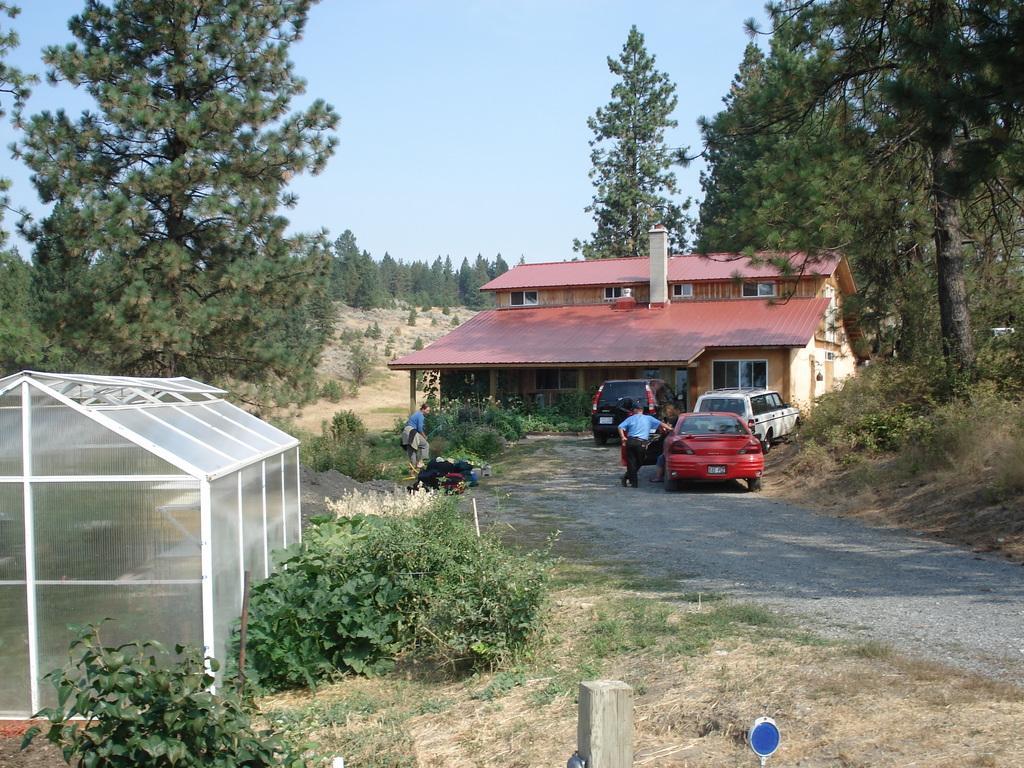Can you describe this image briefly? In the picture I can see a building, plants people standing on the ground, vehicles on the road, trees, the grass and some other objects on the ground. In the background I can see the sky. 